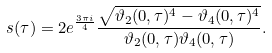Convert formula to latex. <formula><loc_0><loc_0><loc_500><loc_500>s ( \tau ) = 2 e ^ { \frac { 3 \pi i } { 4 } } \frac { \sqrt { \vartheta _ { 2 } ( 0 , \tau ) ^ { 4 } - \vartheta _ { 4 } ( 0 , \tau ) ^ { 4 } } } { \vartheta _ { 2 } ( 0 , \tau ) \vartheta _ { 4 } ( 0 , \tau ) } .</formula> 